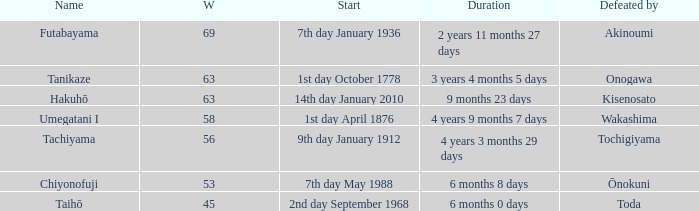What is the Duration for less than 53 consecutive wins? 6 months 0 days. 